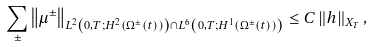<formula> <loc_0><loc_0><loc_500><loc_500>\sum _ { \pm } \left \| \mu ^ { \pm } \right \| _ { L ^ { 2 } \left ( 0 , T ; H ^ { 2 } \left ( \Omega ^ { \pm } ( t ) \right ) \right ) \cap L ^ { 6 } \left ( 0 , T ; H ^ { 1 } \left ( \Omega ^ { \pm } ( t ) \right ) \right ) } & \leq C \left \| h \right \| _ { X _ { T } } ,</formula> 